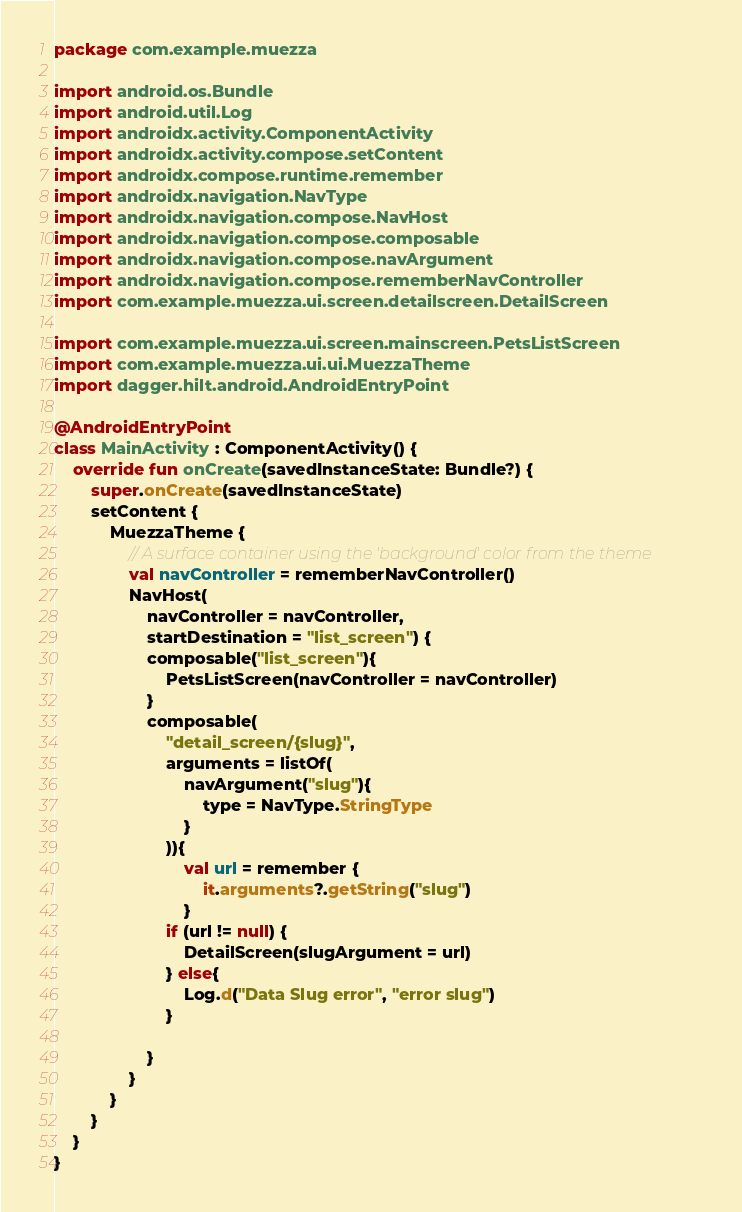Convert code to text. <code><loc_0><loc_0><loc_500><loc_500><_Kotlin_>package com.example.muezza

import android.os.Bundle
import android.util.Log
import androidx.activity.ComponentActivity
import androidx.activity.compose.setContent
import androidx.compose.runtime.remember
import androidx.navigation.NavType
import androidx.navigation.compose.NavHost
import androidx.navigation.compose.composable
import androidx.navigation.compose.navArgument
import androidx.navigation.compose.rememberNavController
import com.example.muezza.ui.screen.detailscreen.DetailScreen

import com.example.muezza.ui.screen.mainscreen.PetsListScreen
import com.example.muezza.ui.ui.MuezzaTheme
import dagger.hilt.android.AndroidEntryPoint

@AndroidEntryPoint
class MainActivity : ComponentActivity() {
    override fun onCreate(savedInstanceState: Bundle?) {
        super.onCreate(savedInstanceState)
        setContent {
            MuezzaTheme {
                // A surface container using the 'background' color from the theme
                val navController = rememberNavController()
                NavHost(
                    navController = navController,
                    startDestination = "list_screen") {
                    composable("list_screen"){
                        PetsListScreen(navController = navController)
                    }
                    composable(
                        "detail_screen/{slug}",
                        arguments = listOf(
                            navArgument("slug"){
                                type = NavType.StringType
                            }
                        )){
                            val url = remember {
                                it.arguments?.getString("slug")
                            }
                        if (url != null) {
                            DetailScreen(slugArgument = url)
                        } else{
                            Log.d("Data Slug error", "error slug")
                        }

                    }
                }
            }
        }
    }
}

</code> 